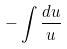Convert formula to latex. <formula><loc_0><loc_0><loc_500><loc_500>- \int \frac { d u } { u }</formula> 